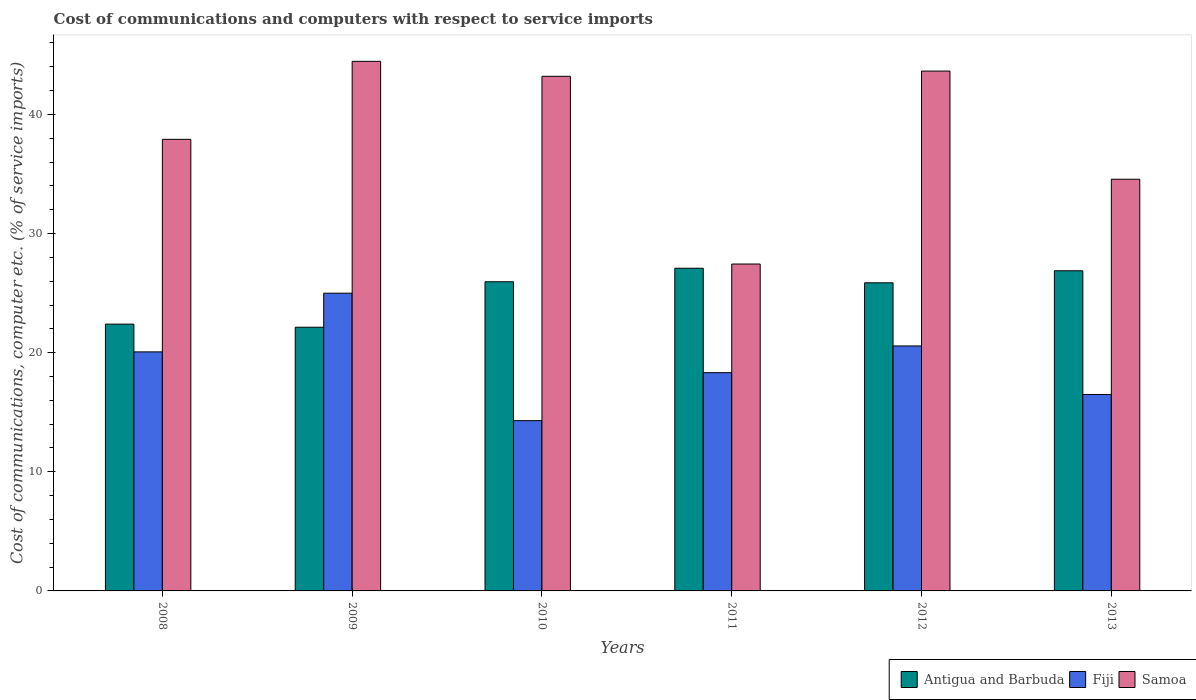Are the number of bars on each tick of the X-axis equal?
Keep it short and to the point. Yes. What is the cost of communications and computers in Antigua and Barbuda in 2011?
Provide a short and direct response. 27.09. Across all years, what is the maximum cost of communications and computers in Antigua and Barbuda?
Give a very brief answer. 27.09. Across all years, what is the minimum cost of communications and computers in Fiji?
Ensure brevity in your answer.  14.29. In which year was the cost of communications and computers in Fiji maximum?
Offer a terse response. 2009. In which year was the cost of communications and computers in Samoa minimum?
Keep it short and to the point. 2011. What is the total cost of communications and computers in Samoa in the graph?
Your answer should be compact. 231.22. What is the difference between the cost of communications and computers in Samoa in 2008 and that in 2010?
Ensure brevity in your answer.  -5.29. What is the difference between the cost of communications and computers in Samoa in 2011 and the cost of communications and computers in Antigua and Barbuda in 2013?
Provide a short and direct response. 0.57. What is the average cost of communications and computers in Samoa per year?
Keep it short and to the point. 38.54. In the year 2012, what is the difference between the cost of communications and computers in Samoa and cost of communications and computers in Antigua and Barbuda?
Your answer should be very brief. 17.78. In how many years, is the cost of communications and computers in Samoa greater than 20 %?
Your response must be concise. 6. What is the ratio of the cost of communications and computers in Antigua and Barbuda in 2010 to that in 2012?
Your answer should be very brief. 1. Is the cost of communications and computers in Antigua and Barbuda in 2008 less than that in 2010?
Offer a very short reply. Yes. Is the difference between the cost of communications and computers in Samoa in 2011 and 2013 greater than the difference between the cost of communications and computers in Antigua and Barbuda in 2011 and 2013?
Ensure brevity in your answer.  No. What is the difference between the highest and the second highest cost of communications and computers in Antigua and Barbuda?
Your response must be concise. 0.21. What is the difference between the highest and the lowest cost of communications and computers in Antigua and Barbuda?
Your answer should be very brief. 4.95. What does the 1st bar from the left in 2011 represents?
Your answer should be compact. Antigua and Barbuda. What does the 1st bar from the right in 2012 represents?
Make the answer very short. Samoa. Is it the case that in every year, the sum of the cost of communications and computers in Fiji and cost of communications and computers in Samoa is greater than the cost of communications and computers in Antigua and Barbuda?
Ensure brevity in your answer.  Yes. Are all the bars in the graph horizontal?
Make the answer very short. No. How many years are there in the graph?
Provide a short and direct response. 6. Are the values on the major ticks of Y-axis written in scientific E-notation?
Offer a very short reply. No. Does the graph contain grids?
Your response must be concise. No. How many legend labels are there?
Make the answer very short. 3. What is the title of the graph?
Offer a terse response. Cost of communications and computers with respect to service imports. What is the label or title of the Y-axis?
Keep it short and to the point. Cost of communications, computer etc. (% of service imports). What is the Cost of communications, computer etc. (% of service imports) of Antigua and Barbuda in 2008?
Make the answer very short. 22.4. What is the Cost of communications, computer etc. (% of service imports) of Fiji in 2008?
Offer a terse response. 20.07. What is the Cost of communications, computer etc. (% of service imports) in Samoa in 2008?
Provide a succinct answer. 37.91. What is the Cost of communications, computer etc. (% of service imports) in Antigua and Barbuda in 2009?
Ensure brevity in your answer.  22.14. What is the Cost of communications, computer etc. (% of service imports) of Fiji in 2009?
Offer a very short reply. 24.99. What is the Cost of communications, computer etc. (% of service imports) in Samoa in 2009?
Your answer should be compact. 44.46. What is the Cost of communications, computer etc. (% of service imports) in Antigua and Barbuda in 2010?
Your answer should be compact. 25.95. What is the Cost of communications, computer etc. (% of service imports) of Fiji in 2010?
Your answer should be very brief. 14.29. What is the Cost of communications, computer etc. (% of service imports) in Samoa in 2010?
Your response must be concise. 43.2. What is the Cost of communications, computer etc. (% of service imports) in Antigua and Barbuda in 2011?
Your response must be concise. 27.09. What is the Cost of communications, computer etc. (% of service imports) in Fiji in 2011?
Offer a terse response. 18.32. What is the Cost of communications, computer etc. (% of service imports) of Samoa in 2011?
Give a very brief answer. 27.44. What is the Cost of communications, computer etc. (% of service imports) in Antigua and Barbuda in 2012?
Offer a very short reply. 25.87. What is the Cost of communications, computer etc. (% of service imports) of Fiji in 2012?
Your answer should be compact. 20.57. What is the Cost of communications, computer etc. (% of service imports) of Samoa in 2012?
Make the answer very short. 43.64. What is the Cost of communications, computer etc. (% of service imports) of Antigua and Barbuda in 2013?
Offer a terse response. 26.88. What is the Cost of communications, computer etc. (% of service imports) in Fiji in 2013?
Provide a short and direct response. 16.49. What is the Cost of communications, computer etc. (% of service imports) of Samoa in 2013?
Provide a short and direct response. 34.56. Across all years, what is the maximum Cost of communications, computer etc. (% of service imports) in Antigua and Barbuda?
Provide a succinct answer. 27.09. Across all years, what is the maximum Cost of communications, computer etc. (% of service imports) in Fiji?
Ensure brevity in your answer.  24.99. Across all years, what is the maximum Cost of communications, computer etc. (% of service imports) in Samoa?
Your answer should be compact. 44.46. Across all years, what is the minimum Cost of communications, computer etc. (% of service imports) in Antigua and Barbuda?
Keep it short and to the point. 22.14. Across all years, what is the minimum Cost of communications, computer etc. (% of service imports) of Fiji?
Your answer should be compact. 14.29. Across all years, what is the minimum Cost of communications, computer etc. (% of service imports) of Samoa?
Offer a very short reply. 27.44. What is the total Cost of communications, computer etc. (% of service imports) in Antigua and Barbuda in the graph?
Make the answer very short. 150.32. What is the total Cost of communications, computer etc. (% of service imports) of Fiji in the graph?
Offer a very short reply. 114.74. What is the total Cost of communications, computer etc. (% of service imports) of Samoa in the graph?
Give a very brief answer. 231.22. What is the difference between the Cost of communications, computer etc. (% of service imports) in Antigua and Barbuda in 2008 and that in 2009?
Keep it short and to the point. 0.26. What is the difference between the Cost of communications, computer etc. (% of service imports) of Fiji in 2008 and that in 2009?
Your answer should be compact. -4.93. What is the difference between the Cost of communications, computer etc. (% of service imports) of Samoa in 2008 and that in 2009?
Ensure brevity in your answer.  -6.55. What is the difference between the Cost of communications, computer etc. (% of service imports) in Antigua and Barbuda in 2008 and that in 2010?
Offer a very short reply. -3.56. What is the difference between the Cost of communications, computer etc. (% of service imports) of Fiji in 2008 and that in 2010?
Provide a short and direct response. 5.77. What is the difference between the Cost of communications, computer etc. (% of service imports) of Samoa in 2008 and that in 2010?
Your answer should be compact. -5.29. What is the difference between the Cost of communications, computer etc. (% of service imports) of Antigua and Barbuda in 2008 and that in 2011?
Provide a succinct answer. -4.69. What is the difference between the Cost of communications, computer etc. (% of service imports) in Fiji in 2008 and that in 2011?
Your response must be concise. 1.75. What is the difference between the Cost of communications, computer etc. (% of service imports) of Samoa in 2008 and that in 2011?
Keep it short and to the point. 10.47. What is the difference between the Cost of communications, computer etc. (% of service imports) in Antigua and Barbuda in 2008 and that in 2012?
Your answer should be compact. -3.47. What is the difference between the Cost of communications, computer etc. (% of service imports) in Fiji in 2008 and that in 2012?
Provide a succinct answer. -0.5. What is the difference between the Cost of communications, computer etc. (% of service imports) of Samoa in 2008 and that in 2012?
Give a very brief answer. -5.73. What is the difference between the Cost of communications, computer etc. (% of service imports) of Antigua and Barbuda in 2008 and that in 2013?
Offer a very short reply. -4.48. What is the difference between the Cost of communications, computer etc. (% of service imports) in Fiji in 2008 and that in 2013?
Provide a short and direct response. 3.58. What is the difference between the Cost of communications, computer etc. (% of service imports) in Samoa in 2008 and that in 2013?
Provide a short and direct response. 3.35. What is the difference between the Cost of communications, computer etc. (% of service imports) in Antigua and Barbuda in 2009 and that in 2010?
Provide a succinct answer. -3.82. What is the difference between the Cost of communications, computer etc. (% of service imports) of Fiji in 2009 and that in 2010?
Offer a very short reply. 10.7. What is the difference between the Cost of communications, computer etc. (% of service imports) in Samoa in 2009 and that in 2010?
Provide a short and direct response. 1.26. What is the difference between the Cost of communications, computer etc. (% of service imports) of Antigua and Barbuda in 2009 and that in 2011?
Offer a terse response. -4.95. What is the difference between the Cost of communications, computer etc. (% of service imports) in Fiji in 2009 and that in 2011?
Provide a succinct answer. 6.67. What is the difference between the Cost of communications, computer etc. (% of service imports) in Samoa in 2009 and that in 2011?
Ensure brevity in your answer.  17.01. What is the difference between the Cost of communications, computer etc. (% of service imports) of Antigua and Barbuda in 2009 and that in 2012?
Your answer should be compact. -3.73. What is the difference between the Cost of communications, computer etc. (% of service imports) of Fiji in 2009 and that in 2012?
Your answer should be compact. 4.43. What is the difference between the Cost of communications, computer etc. (% of service imports) of Samoa in 2009 and that in 2012?
Your answer should be very brief. 0.82. What is the difference between the Cost of communications, computer etc. (% of service imports) in Antigua and Barbuda in 2009 and that in 2013?
Give a very brief answer. -4.74. What is the difference between the Cost of communications, computer etc. (% of service imports) in Fiji in 2009 and that in 2013?
Provide a short and direct response. 8.5. What is the difference between the Cost of communications, computer etc. (% of service imports) of Samoa in 2009 and that in 2013?
Keep it short and to the point. 9.9. What is the difference between the Cost of communications, computer etc. (% of service imports) in Antigua and Barbuda in 2010 and that in 2011?
Make the answer very short. -1.14. What is the difference between the Cost of communications, computer etc. (% of service imports) in Fiji in 2010 and that in 2011?
Provide a succinct answer. -4.03. What is the difference between the Cost of communications, computer etc. (% of service imports) in Samoa in 2010 and that in 2011?
Make the answer very short. 15.76. What is the difference between the Cost of communications, computer etc. (% of service imports) of Antigua and Barbuda in 2010 and that in 2012?
Make the answer very short. 0.09. What is the difference between the Cost of communications, computer etc. (% of service imports) in Fiji in 2010 and that in 2012?
Make the answer very short. -6.27. What is the difference between the Cost of communications, computer etc. (% of service imports) in Samoa in 2010 and that in 2012?
Provide a short and direct response. -0.44. What is the difference between the Cost of communications, computer etc. (% of service imports) of Antigua and Barbuda in 2010 and that in 2013?
Ensure brevity in your answer.  -0.92. What is the difference between the Cost of communications, computer etc. (% of service imports) in Fiji in 2010 and that in 2013?
Give a very brief answer. -2.2. What is the difference between the Cost of communications, computer etc. (% of service imports) in Samoa in 2010 and that in 2013?
Ensure brevity in your answer.  8.64. What is the difference between the Cost of communications, computer etc. (% of service imports) of Antigua and Barbuda in 2011 and that in 2012?
Your answer should be compact. 1.22. What is the difference between the Cost of communications, computer etc. (% of service imports) of Fiji in 2011 and that in 2012?
Your response must be concise. -2.24. What is the difference between the Cost of communications, computer etc. (% of service imports) in Samoa in 2011 and that in 2012?
Give a very brief answer. -16.2. What is the difference between the Cost of communications, computer etc. (% of service imports) of Antigua and Barbuda in 2011 and that in 2013?
Provide a short and direct response. 0.21. What is the difference between the Cost of communications, computer etc. (% of service imports) in Fiji in 2011 and that in 2013?
Offer a terse response. 1.83. What is the difference between the Cost of communications, computer etc. (% of service imports) in Samoa in 2011 and that in 2013?
Provide a succinct answer. -7.12. What is the difference between the Cost of communications, computer etc. (% of service imports) in Antigua and Barbuda in 2012 and that in 2013?
Offer a terse response. -1.01. What is the difference between the Cost of communications, computer etc. (% of service imports) in Fiji in 2012 and that in 2013?
Offer a very short reply. 4.08. What is the difference between the Cost of communications, computer etc. (% of service imports) of Samoa in 2012 and that in 2013?
Give a very brief answer. 9.08. What is the difference between the Cost of communications, computer etc. (% of service imports) of Antigua and Barbuda in 2008 and the Cost of communications, computer etc. (% of service imports) of Fiji in 2009?
Provide a short and direct response. -2.6. What is the difference between the Cost of communications, computer etc. (% of service imports) of Antigua and Barbuda in 2008 and the Cost of communications, computer etc. (% of service imports) of Samoa in 2009?
Offer a very short reply. -22.06. What is the difference between the Cost of communications, computer etc. (% of service imports) of Fiji in 2008 and the Cost of communications, computer etc. (% of service imports) of Samoa in 2009?
Provide a succinct answer. -24.39. What is the difference between the Cost of communications, computer etc. (% of service imports) in Antigua and Barbuda in 2008 and the Cost of communications, computer etc. (% of service imports) in Fiji in 2010?
Offer a terse response. 8.1. What is the difference between the Cost of communications, computer etc. (% of service imports) in Antigua and Barbuda in 2008 and the Cost of communications, computer etc. (% of service imports) in Samoa in 2010?
Your answer should be very brief. -20.8. What is the difference between the Cost of communications, computer etc. (% of service imports) of Fiji in 2008 and the Cost of communications, computer etc. (% of service imports) of Samoa in 2010?
Your response must be concise. -23.14. What is the difference between the Cost of communications, computer etc. (% of service imports) in Antigua and Barbuda in 2008 and the Cost of communications, computer etc. (% of service imports) in Fiji in 2011?
Your answer should be very brief. 4.08. What is the difference between the Cost of communications, computer etc. (% of service imports) of Antigua and Barbuda in 2008 and the Cost of communications, computer etc. (% of service imports) of Samoa in 2011?
Ensure brevity in your answer.  -5.05. What is the difference between the Cost of communications, computer etc. (% of service imports) in Fiji in 2008 and the Cost of communications, computer etc. (% of service imports) in Samoa in 2011?
Your response must be concise. -7.38. What is the difference between the Cost of communications, computer etc. (% of service imports) of Antigua and Barbuda in 2008 and the Cost of communications, computer etc. (% of service imports) of Fiji in 2012?
Ensure brevity in your answer.  1.83. What is the difference between the Cost of communications, computer etc. (% of service imports) of Antigua and Barbuda in 2008 and the Cost of communications, computer etc. (% of service imports) of Samoa in 2012?
Keep it short and to the point. -21.24. What is the difference between the Cost of communications, computer etc. (% of service imports) of Fiji in 2008 and the Cost of communications, computer etc. (% of service imports) of Samoa in 2012?
Keep it short and to the point. -23.57. What is the difference between the Cost of communications, computer etc. (% of service imports) in Antigua and Barbuda in 2008 and the Cost of communications, computer etc. (% of service imports) in Fiji in 2013?
Your answer should be compact. 5.91. What is the difference between the Cost of communications, computer etc. (% of service imports) of Antigua and Barbuda in 2008 and the Cost of communications, computer etc. (% of service imports) of Samoa in 2013?
Your answer should be compact. -12.16. What is the difference between the Cost of communications, computer etc. (% of service imports) of Fiji in 2008 and the Cost of communications, computer etc. (% of service imports) of Samoa in 2013?
Make the answer very short. -14.49. What is the difference between the Cost of communications, computer etc. (% of service imports) in Antigua and Barbuda in 2009 and the Cost of communications, computer etc. (% of service imports) in Fiji in 2010?
Keep it short and to the point. 7.84. What is the difference between the Cost of communications, computer etc. (% of service imports) in Antigua and Barbuda in 2009 and the Cost of communications, computer etc. (% of service imports) in Samoa in 2010?
Ensure brevity in your answer.  -21.07. What is the difference between the Cost of communications, computer etc. (% of service imports) in Fiji in 2009 and the Cost of communications, computer etc. (% of service imports) in Samoa in 2010?
Your response must be concise. -18.21. What is the difference between the Cost of communications, computer etc. (% of service imports) of Antigua and Barbuda in 2009 and the Cost of communications, computer etc. (% of service imports) of Fiji in 2011?
Provide a succinct answer. 3.81. What is the difference between the Cost of communications, computer etc. (% of service imports) of Antigua and Barbuda in 2009 and the Cost of communications, computer etc. (% of service imports) of Samoa in 2011?
Your answer should be compact. -5.31. What is the difference between the Cost of communications, computer etc. (% of service imports) in Fiji in 2009 and the Cost of communications, computer etc. (% of service imports) in Samoa in 2011?
Your answer should be very brief. -2.45. What is the difference between the Cost of communications, computer etc. (% of service imports) of Antigua and Barbuda in 2009 and the Cost of communications, computer etc. (% of service imports) of Fiji in 2012?
Provide a short and direct response. 1.57. What is the difference between the Cost of communications, computer etc. (% of service imports) in Antigua and Barbuda in 2009 and the Cost of communications, computer etc. (% of service imports) in Samoa in 2012?
Keep it short and to the point. -21.51. What is the difference between the Cost of communications, computer etc. (% of service imports) in Fiji in 2009 and the Cost of communications, computer etc. (% of service imports) in Samoa in 2012?
Give a very brief answer. -18.65. What is the difference between the Cost of communications, computer etc. (% of service imports) in Antigua and Barbuda in 2009 and the Cost of communications, computer etc. (% of service imports) in Fiji in 2013?
Your answer should be compact. 5.65. What is the difference between the Cost of communications, computer etc. (% of service imports) of Antigua and Barbuda in 2009 and the Cost of communications, computer etc. (% of service imports) of Samoa in 2013?
Your answer should be very brief. -12.42. What is the difference between the Cost of communications, computer etc. (% of service imports) of Fiji in 2009 and the Cost of communications, computer etc. (% of service imports) of Samoa in 2013?
Offer a terse response. -9.57. What is the difference between the Cost of communications, computer etc. (% of service imports) of Antigua and Barbuda in 2010 and the Cost of communications, computer etc. (% of service imports) of Fiji in 2011?
Your answer should be very brief. 7.63. What is the difference between the Cost of communications, computer etc. (% of service imports) of Antigua and Barbuda in 2010 and the Cost of communications, computer etc. (% of service imports) of Samoa in 2011?
Provide a succinct answer. -1.49. What is the difference between the Cost of communications, computer etc. (% of service imports) in Fiji in 2010 and the Cost of communications, computer etc. (% of service imports) in Samoa in 2011?
Provide a short and direct response. -13.15. What is the difference between the Cost of communications, computer etc. (% of service imports) in Antigua and Barbuda in 2010 and the Cost of communications, computer etc. (% of service imports) in Fiji in 2012?
Offer a very short reply. 5.39. What is the difference between the Cost of communications, computer etc. (% of service imports) in Antigua and Barbuda in 2010 and the Cost of communications, computer etc. (% of service imports) in Samoa in 2012?
Make the answer very short. -17.69. What is the difference between the Cost of communications, computer etc. (% of service imports) of Fiji in 2010 and the Cost of communications, computer etc. (% of service imports) of Samoa in 2012?
Your response must be concise. -29.35. What is the difference between the Cost of communications, computer etc. (% of service imports) of Antigua and Barbuda in 2010 and the Cost of communications, computer etc. (% of service imports) of Fiji in 2013?
Your answer should be compact. 9.46. What is the difference between the Cost of communications, computer etc. (% of service imports) of Antigua and Barbuda in 2010 and the Cost of communications, computer etc. (% of service imports) of Samoa in 2013?
Your answer should be very brief. -8.61. What is the difference between the Cost of communications, computer etc. (% of service imports) in Fiji in 2010 and the Cost of communications, computer etc. (% of service imports) in Samoa in 2013?
Offer a terse response. -20.27. What is the difference between the Cost of communications, computer etc. (% of service imports) of Antigua and Barbuda in 2011 and the Cost of communications, computer etc. (% of service imports) of Fiji in 2012?
Provide a succinct answer. 6.52. What is the difference between the Cost of communications, computer etc. (% of service imports) in Antigua and Barbuda in 2011 and the Cost of communications, computer etc. (% of service imports) in Samoa in 2012?
Give a very brief answer. -16.55. What is the difference between the Cost of communications, computer etc. (% of service imports) in Fiji in 2011 and the Cost of communications, computer etc. (% of service imports) in Samoa in 2012?
Provide a short and direct response. -25.32. What is the difference between the Cost of communications, computer etc. (% of service imports) of Antigua and Barbuda in 2011 and the Cost of communications, computer etc. (% of service imports) of Fiji in 2013?
Provide a succinct answer. 10.6. What is the difference between the Cost of communications, computer etc. (% of service imports) of Antigua and Barbuda in 2011 and the Cost of communications, computer etc. (% of service imports) of Samoa in 2013?
Offer a terse response. -7.47. What is the difference between the Cost of communications, computer etc. (% of service imports) of Fiji in 2011 and the Cost of communications, computer etc. (% of service imports) of Samoa in 2013?
Your answer should be compact. -16.24. What is the difference between the Cost of communications, computer etc. (% of service imports) in Antigua and Barbuda in 2012 and the Cost of communications, computer etc. (% of service imports) in Fiji in 2013?
Your answer should be compact. 9.38. What is the difference between the Cost of communications, computer etc. (% of service imports) in Antigua and Barbuda in 2012 and the Cost of communications, computer etc. (% of service imports) in Samoa in 2013?
Your answer should be compact. -8.69. What is the difference between the Cost of communications, computer etc. (% of service imports) of Fiji in 2012 and the Cost of communications, computer etc. (% of service imports) of Samoa in 2013?
Give a very brief answer. -13.99. What is the average Cost of communications, computer etc. (% of service imports) in Antigua and Barbuda per year?
Offer a very short reply. 25.05. What is the average Cost of communications, computer etc. (% of service imports) of Fiji per year?
Give a very brief answer. 19.12. What is the average Cost of communications, computer etc. (% of service imports) in Samoa per year?
Provide a short and direct response. 38.54. In the year 2008, what is the difference between the Cost of communications, computer etc. (% of service imports) of Antigua and Barbuda and Cost of communications, computer etc. (% of service imports) of Fiji?
Offer a very short reply. 2.33. In the year 2008, what is the difference between the Cost of communications, computer etc. (% of service imports) of Antigua and Barbuda and Cost of communications, computer etc. (% of service imports) of Samoa?
Provide a succinct answer. -15.51. In the year 2008, what is the difference between the Cost of communications, computer etc. (% of service imports) in Fiji and Cost of communications, computer etc. (% of service imports) in Samoa?
Give a very brief answer. -17.84. In the year 2009, what is the difference between the Cost of communications, computer etc. (% of service imports) in Antigua and Barbuda and Cost of communications, computer etc. (% of service imports) in Fiji?
Ensure brevity in your answer.  -2.86. In the year 2009, what is the difference between the Cost of communications, computer etc. (% of service imports) of Antigua and Barbuda and Cost of communications, computer etc. (% of service imports) of Samoa?
Ensure brevity in your answer.  -22.32. In the year 2009, what is the difference between the Cost of communications, computer etc. (% of service imports) in Fiji and Cost of communications, computer etc. (% of service imports) in Samoa?
Provide a succinct answer. -19.46. In the year 2010, what is the difference between the Cost of communications, computer etc. (% of service imports) in Antigua and Barbuda and Cost of communications, computer etc. (% of service imports) in Fiji?
Provide a short and direct response. 11.66. In the year 2010, what is the difference between the Cost of communications, computer etc. (% of service imports) of Antigua and Barbuda and Cost of communications, computer etc. (% of service imports) of Samoa?
Your answer should be compact. -17.25. In the year 2010, what is the difference between the Cost of communications, computer etc. (% of service imports) in Fiji and Cost of communications, computer etc. (% of service imports) in Samoa?
Offer a terse response. -28.91. In the year 2011, what is the difference between the Cost of communications, computer etc. (% of service imports) in Antigua and Barbuda and Cost of communications, computer etc. (% of service imports) in Fiji?
Provide a short and direct response. 8.77. In the year 2011, what is the difference between the Cost of communications, computer etc. (% of service imports) in Antigua and Barbuda and Cost of communications, computer etc. (% of service imports) in Samoa?
Provide a short and direct response. -0.35. In the year 2011, what is the difference between the Cost of communications, computer etc. (% of service imports) in Fiji and Cost of communications, computer etc. (% of service imports) in Samoa?
Give a very brief answer. -9.12. In the year 2012, what is the difference between the Cost of communications, computer etc. (% of service imports) in Antigua and Barbuda and Cost of communications, computer etc. (% of service imports) in Fiji?
Keep it short and to the point. 5.3. In the year 2012, what is the difference between the Cost of communications, computer etc. (% of service imports) in Antigua and Barbuda and Cost of communications, computer etc. (% of service imports) in Samoa?
Offer a very short reply. -17.78. In the year 2012, what is the difference between the Cost of communications, computer etc. (% of service imports) of Fiji and Cost of communications, computer etc. (% of service imports) of Samoa?
Ensure brevity in your answer.  -23.08. In the year 2013, what is the difference between the Cost of communications, computer etc. (% of service imports) of Antigua and Barbuda and Cost of communications, computer etc. (% of service imports) of Fiji?
Provide a short and direct response. 10.39. In the year 2013, what is the difference between the Cost of communications, computer etc. (% of service imports) of Antigua and Barbuda and Cost of communications, computer etc. (% of service imports) of Samoa?
Ensure brevity in your answer.  -7.68. In the year 2013, what is the difference between the Cost of communications, computer etc. (% of service imports) in Fiji and Cost of communications, computer etc. (% of service imports) in Samoa?
Provide a succinct answer. -18.07. What is the ratio of the Cost of communications, computer etc. (% of service imports) in Antigua and Barbuda in 2008 to that in 2009?
Your response must be concise. 1.01. What is the ratio of the Cost of communications, computer etc. (% of service imports) in Fiji in 2008 to that in 2009?
Keep it short and to the point. 0.8. What is the ratio of the Cost of communications, computer etc. (% of service imports) in Samoa in 2008 to that in 2009?
Ensure brevity in your answer.  0.85. What is the ratio of the Cost of communications, computer etc. (% of service imports) of Antigua and Barbuda in 2008 to that in 2010?
Your answer should be compact. 0.86. What is the ratio of the Cost of communications, computer etc. (% of service imports) in Fiji in 2008 to that in 2010?
Make the answer very short. 1.4. What is the ratio of the Cost of communications, computer etc. (% of service imports) in Samoa in 2008 to that in 2010?
Keep it short and to the point. 0.88. What is the ratio of the Cost of communications, computer etc. (% of service imports) in Antigua and Barbuda in 2008 to that in 2011?
Your answer should be compact. 0.83. What is the ratio of the Cost of communications, computer etc. (% of service imports) of Fiji in 2008 to that in 2011?
Your answer should be very brief. 1.1. What is the ratio of the Cost of communications, computer etc. (% of service imports) of Samoa in 2008 to that in 2011?
Ensure brevity in your answer.  1.38. What is the ratio of the Cost of communications, computer etc. (% of service imports) of Antigua and Barbuda in 2008 to that in 2012?
Your answer should be very brief. 0.87. What is the ratio of the Cost of communications, computer etc. (% of service imports) of Fiji in 2008 to that in 2012?
Offer a very short reply. 0.98. What is the ratio of the Cost of communications, computer etc. (% of service imports) in Samoa in 2008 to that in 2012?
Provide a succinct answer. 0.87. What is the ratio of the Cost of communications, computer etc. (% of service imports) of Fiji in 2008 to that in 2013?
Give a very brief answer. 1.22. What is the ratio of the Cost of communications, computer etc. (% of service imports) of Samoa in 2008 to that in 2013?
Offer a terse response. 1.1. What is the ratio of the Cost of communications, computer etc. (% of service imports) in Antigua and Barbuda in 2009 to that in 2010?
Offer a terse response. 0.85. What is the ratio of the Cost of communications, computer etc. (% of service imports) in Fiji in 2009 to that in 2010?
Give a very brief answer. 1.75. What is the ratio of the Cost of communications, computer etc. (% of service imports) of Samoa in 2009 to that in 2010?
Your answer should be very brief. 1.03. What is the ratio of the Cost of communications, computer etc. (% of service imports) in Antigua and Barbuda in 2009 to that in 2011?
Provide a short and direct response. 0.82. What is the ratio of the Cost of communications, computer etc. (% of service imports) in Fiji in 2009 to that in 2011?
Offer a terse response. 1.36. What is the ratio of the Cost of communications, computer etc. (% of service imports) of Samoa in 2009 to that in 2011?
Your answer should be compact. 1.62. What is the ratio of the Cost of communications, computer etc. (% of service imports) in Antigua and Barbuda in 2009 to that in 2012?
Give a very brief answer. 0.86. What is the ratio of the Cost of communications, computer etc. (% of service imports) in Fiji in 2009 to that in 2012?
Your response must be concise. 1.22. What is the ratio of the Cost of communications, computer etc. (% of service imports) in Samoa in 2009 to that in 2012?
Keep it short and to the point. 1.02. What is the ratio of the Cost of communications, computer etc. (% of service imports) in Antigua and Barbuda in 2009 to that in 2013?
Your answer should be compact. 0.82. What is the ratio of the Cost of communications, computer etc. (% of service imports) of Fiji in 2009 to that in 2013?
Make the answer very short. 1.52. What is the ratio of the Cost of communications, computer etc. (% of service imports) of Samoa in 2009 to that in 2013?
Keep it short and to the point. 1.29. What is the ratio of the Cost of communications, computer etc. (% of service imports) of Antigua and Barbuda in 2010 to that in 2011?
Your answer should be compact. 0.96. What is the ratio of the Cost of communications, computer etc. (% of service imports) of Fiji in 2010 to that in 2011?
Provide a succinct answer. 0.78. What is the ratio of the Cost of communications, computer etc. (% of service imports) of Samoa in 2010 to that in 2011?
Offer a very short reply. 1.57. What is the ratio of the Cost of communications, computer etc. (% of service imports) in Fiji in 2010 to that in 2012?
Give a very brief answer. 0.69. What is the ratio of the Cost of communications, computer etc. (% of service imports) in Antigua and Barbuda in 2010 to that in 2013?
Your answer should be very brief. 0.97. What is the ratio of the Cost of communications, computer etc. (% of service imports) of Fiji in 2010 to that in 2013?
Provide a short and direct response. 0.87. What is the ratio of the Cost of communications, computer etc. (% of service imports) of Samoa in 2010 to that in 2013?
Your answer should be compact. 1.25. What is the ratio of the Cost of communications, computer etc. (% of service imports) of Antigua and Barbuda in 2011 to that in 2012?
Your answer should be very brief. 1.05. What is the ratio of the Cost of communications, computer etc. (% of service imports) of Fiji in 2011 to that in 2012?
Provide a succinct answer. 0.89. What is the ratio of the Cost of communications, computer etc. (% of service imports) in Samoa in 2011 to that in 2012?
Your response must be concise. 0.63. What is the ratio of the Cost of communications, computer etc. (% of service imports) in Antigua and Barbuda in 2011 to that in 2013?
Your answer should be compact. 1.01. What is the ratio of the Cost of communications, computer etc. (% of service imports) in Fiji in 2011 to that in 2013?
Your answer should be compact. 1.11. What is the ratio of the Cost of communications, computer etc. (% of service imports) in Samoa in 2011 to that in 2013?
Offer a very short reply. 0.79. What is the ratio of the Cost of communications, computer etc. (% of service imports) in Antigua and Barbuda in 2012 to that in 2013?
Offer a very short reply. 0.96. What is the ratio of the Cost of communications, computer etc. (% of service imports) of Fiji in 2012 to that in 2013?
Your answer should be compact. 1.25. What is the ratio of the Cost of communications, computer etc. (% of service imports) of Samoa in 2012 to that in 2013?
Offer a terse response. 1.26. What is the difference between the highest and the second highest Cost of communications, computer etc. (% of service imports) in Antigua and Barbuda?
Your answer should be very brief. 0.21. What is the difference between the highest and the second highest Cost of communications, computer etc. (% of service imports) in Fiji?
Your response must be concise. 4.43. What is the difference between the highest and the second highest Cost of communications, computer etc. (% of service imports) in Samoa?
Keep it short and to the point. 0.82. What is the difference between the highest and the lowest Cost of communications, computer etc. (% of service imports) of Antigua and Barbuda?
Your answer should be compact. 4.95. What is the difference between the highest and the lowest Cost of communications, computer etc. (% of service imports) in Fiji?
Offer a terse response. 10.7. What is the difference between the highest and the lowest Cost of communications, computer etc. (% of service imports) in Samoa?
Your answer should be very brief. 17.01. 